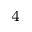Convert formula to latex. <formula><loc_0><loc_0><loc_500><loc_500>_ { 4 }</formula> 